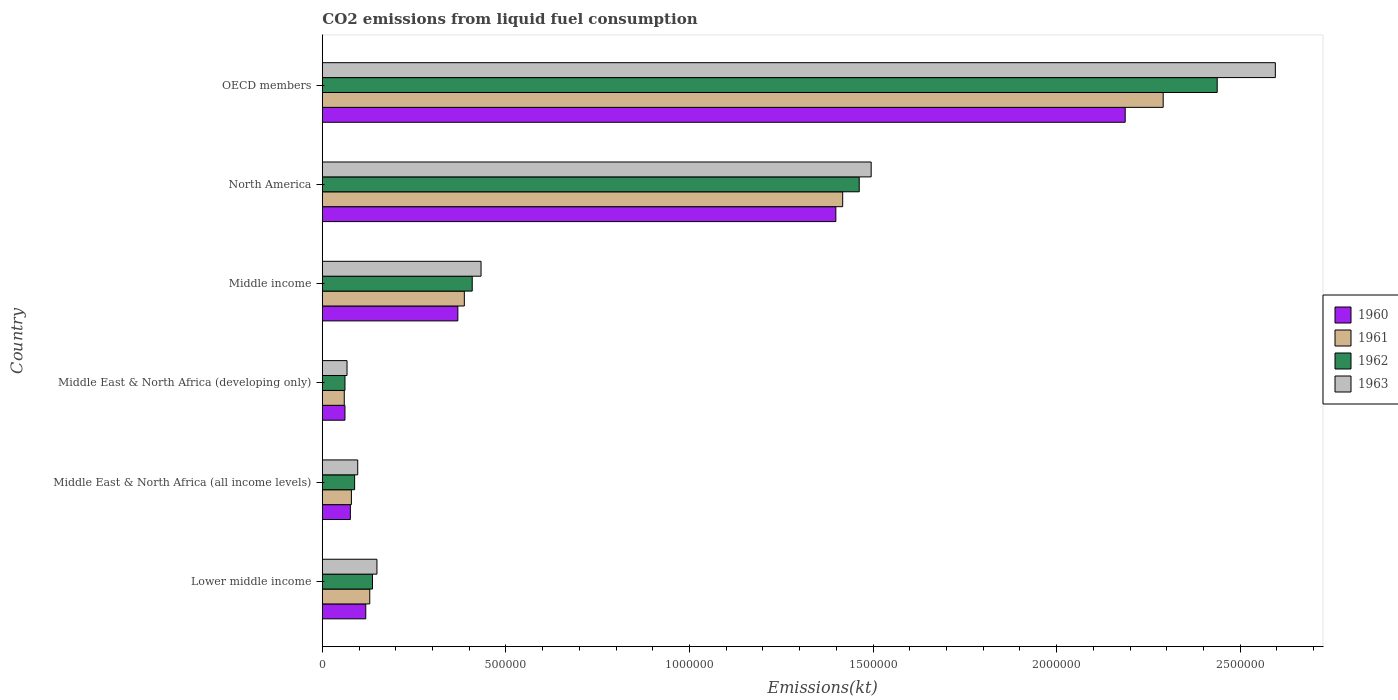How many different coloured bars are there?
Give a very brief answer. 4. How many groups of bars are there?
Keep it short and to the point. 6. Are the number of bars on each tick of the Y-axis equal?
Keep it short and to the point. Yes. How many bars are there on the 3rd tick from the top?
Offer a terse response. 4. How many bars are there on the 2nd tick from the bottom?
Provide a succinct answer. 4. What is the label of the 3rd group of bars from the top?
Your answer should be very brief. Middle income. In how many cases, is the number of bars for a given country not equal to the number of legend labels?
Make the answer very short. 0. What is the amount of CO2 emitted in 1960 in Middle East & North Africa (developing only)?
Offer a very short reply. 6.16e+04. Across all countries, what is the maximum amount of CO2 emitted in 1960?
Give a very brief answer. 2.19e+06. Across all countries, what is the minimum amount of CO2 emitted in 1963?
Offer a very short reply. 6.73e+04. In which country was the amount of CO2 emitted in 1960 maximum?
Ensure brevity in your answer.  OECD members. In which country was the amount of CO2 emitted in 1960 minimum?
Ensure brevity in your answer.  Middle East & North Africa (developing only). What is the total amount of CO2 emitted in 1962 in the graph?
Your response must be concise. 4.59e+06. What is the difference between the amount of CO2 emitted in 1962 in Middle East & North Africa (all income levels) and that in Middle income?
Provide a short and direct response. -3.20e+05. What is the difference between the amount of CO2 emitted in 1961 in Middle income and the amount of CO2 emitted in 1962 in Middle East & North Africa (developing only)?
Your answer should be very brief. 3.25e+05. What is the average amount of CO2 emitted in 1961 per country?
Offer a very short reply. 7.27e+05. What is the difference between the amount of CO2 emitted in 1963 and amount of CO2 emitted in 1962 in Middle East & North Africa (developing only)?
Keep it short and to the point. 5626.64. In how many countries, is the amount of CO2 emitted in 1961 greater than 2300000 kt?
Provide a short and direct response. 0. What is the ratio of the amount of CO2 emitted in 1960 in North America to that in OECD members?
Offer a very short reply. 0.64. Is the amount of CO2 emitted in 1963 in Lower middle income less than that in Middle income?
Provide a short and direct response. Yes. Is the difference between the amount of CO2 emitted in 1963 in Lower middle income and Middle East & North Africa (all income levels) greater than the difference between the amount of CO2 emitted in 1962 in Lower middle income and Middle East & North Africa (all income levels)?
Your answer should be compact. Yes. What is the difference between the highest and the second highest amount of CO2 emitted in 1960?
Your answer should be very brief. 7.88e+05. What is the difference between the highest and the lowest amount of CO2 emitted in 1962?
Your answer should be very brief. 2.38e+06. Is the sum of the amount of CO2 emitted in 1961 in Lower middle income and Middle East & North Africa (developing only) greater than the maximum amount of CO2 emitted in 1960 across all countries?
Your response must be concise. No. What does the 2nd bar from the bottom in OECD members represents?
Offer a very short reply. 1961. Are all the bars in the graph horizontal?
Your response must be concise. Yes. How many countries are there in the graph?
Provide a succinct answer. 6. What is the difference between two consecutive major ticks on the X-axis?
Give a very brief answer. 5.00e+05. Are the values on the major ticks of X-axis written in scientific E-notation?
Ensure brevity in your answer.  No. Does the graph contain grids?
Offer a very short reply. No. Where does the legend appear in the graph?
Your response must be concise. Center right. How many legend labels are there?
Provide a succinct answer. 4. What is the title of the graph?
Make the answer very short. CO2 emissions from liquid fuel consumption. What is the label or title of the X-axis?
Keep it short and to the point. Emissions(kt). What is the Emissions(kt) of 1960 in Lower middle income?
Ensure brevity in your answer.  1.18e+05. What is the Emissions(kt) in 1961 in Lower middle income?
Provide a succinct answer. 1.29e+05. What is the Emissions(kt) of 1962 in Lower middle income?
Provide a short and direct response. 1.37e+05. What is the Emissions(kt) in 1963 in Lower middle income?
Offer a terse response. 1.49e+05. What is the Emissions(kt) of 1960 in Middle East & North Africa (all income levels)?
Give a very brief answer. 7.64e+04. What is the Emissions(kt) in 1961 in Middle East & North Africa (all income levels)?
Your answer should be compact. 7.92e+04. What is the Emissions(kt) of 1962 in Middle East & North Africa (all income levels)?
Offer a very short reply. 8.80e+04. What is the Emissions(kt) in 1963 in Middle East & North Africa (all income levels)?
Your answer should be very brief. 9.64e+04. What is the Emissions(kt) of 1960 in Middle East & North Africa (developing only)?
Your answer should be compact. 6.16e+04. What is the Emissions(kt) in 1961 in Middle East & North Africa (developing only)?
Your answer should be compact. 5.98e+04. What is the Emissions(kt) in 1962 in Middle East & North Africa (developing only)?
Your answer should be compact. 6.17e+04. What is the Emissions(kt) in 1963 in Middle East & North Africa (developing only)?
Offer a terse response. 6.73e+04. What is the Emissions(kt) in 1960 in Middle income?
Your answer should be very brief. 3.69e+05. What is the Emissions(kt) of 1961 in Middle income?
Give a very brief answer. 3.87e+05. What is the Emissions(kt) in 1962 in Middle income?
Your answer should be compact. 4.08e+05. What is the Emissions(kt) in 1963 in Middle income?
Offer a terse response. 4.32e+05. What is the Emissions(kt) of 1960 in North America?
Ensure brevity in your answer.  1.40e+06. What is the Emissions(kt) of 1961 in North America?
Provide a succinct answer. 1.42e+06. What is the Emissions(kt) of 1962 in North America?
Make the answer very short. 1.46e+06. What is the Emissions(kt) in 1963 in North America?
Offer a very short reply. 1.49e+06. What is the Emissions(kt) in 1960 in OECD members?
Provide a succinct answer. 2.19e+06. What is the Emissions(kt) of 1961 in OECD members?
Provide a succinct answer. 2.29e+06. What is the Emissions(kt) of 1962 in OECD members?
Provide a short and direct response. 2.44e+06. What is the Emissions(kt) of 1963 in OECD members?
Your answer should be very brief. 2.60e+06. Across all countries, what is the maximum Emissions(kt) in 1960?
Your answer should be compact. 2.19e+06. Across all countries, what is the maximum Emissions(kt) of 1961?
Your response must be concise. 2.29e+06. Across all countries, what is the maximum Emissions(kt) of 1962?
Offer a very short reply. 2.44e+06. Across all countries, what is the maximum Emissions(kt) of 1963?
Provide a short and direct response. 2.60e+06. Across all countries, what is the minimum Emissions(kt) of 1960?
Your answer should be very brief. 6.16e+04. Across all countries, what is the minimum Emissions(kt) of 1961?
Your answer should be very brief. 5.98e+04. Across all countries, what is the minimum Emissions(kt) of 1962?
Give a very brief answer. 6.17e+04. Across all countries, what is the minimum Emissions(kt) of 1963?
Keep it short and to the point. 6.73e+04. What is the total Emissions(kt) in 1960 in the graph?
Your response must be concise. 4.21e+06. What is the total Emissions(kt) in 1961 in the graph?
Provide a succinct answer. 4.36e+06. What is the total Emissions(kt) of 1962 in the graph?
Make the answer very short. 4.59e+06. What is the total Emissions(kt) in 1963 in the graph?
Your answer should be very brief. 4.84e+06. What is the difference between the Emissions(kt) of 1960 in Lower middle income and that in Middle East & North Africa (all income levels)?
Give a very brief answer. 4.19e+04. What is the difference between the Emissions(kt) of 1961 in Lower middle income and that in Middle East & North Africa (all income levels)?
Offer a terse response. 5.00e+04. What is the difference between the Emissions(kt) in 1962 in Lower middle income and that in Middle East & North Africa (all income levels)?
Make the answer very short. 4.87e+04. What is the difference between the Emissions(kt) in 1963 in Lower middle income and that in Middle East & North Africa (all income levels)?
Your answer should be very brief. 5.23e+04. What is the difference between the Emissions(kt) of 1960 in Lower middle income and that in Middle East & North Africa (developing only)?
Make the answer very short. 5.67e+04. What is the difference between the Emissions(kt) in 1961 in Lower middle income and that in Middle East & North Africa (developing only)?
Make the answer very short. 6.95e+04. What is the difference between the Emissions(kt) in 1962 in Lower middle income and that in Middle East & North Africa (developing only)?
Your answer should be compact. 7.49e+04. What is the difference between the Emissions(kt) in 1963 in Lower middle income and that in Middle East & North Africa (developing only)?
Your answer should be very brief. 8.14e+04. What is the difference between the Emissions(kt) of 1960 in Lower middle income and that in Middle income?
Keep it short and to the point. -2.51e+05. What is the difference between the Emissions(kt) in 1961 in Lower middle income and that in Middle income?
Provide a succinct answer. -2.58e+05. What is the difference between the Emissions(kt) in 1962 in Lower middle income and that in Middle income?
Offer a very short reply. -2.72e+05. What is the difference between the Emissions(kt) of 1963 in Lower middle income and that in Middle income?
Your answer should be very brief. -2.84e+05. What is the difference between the Emissions(kt) of 1960 in Lower middle income and that in North America?
Offer a very short reply. -1.28e+06. What is the difference between the Emissions(kt) in 1961 in Lower middle income and that in North America?
Your answer should be very brief. -1.29e+06. What is the difference between the Emissions(kt) in 1962 in Lower middle income and that in North America?
Make the answer very short. -1.33e+06. What is the difference between the Emissions(kt) of 1963 in Lower middle income and that in North America?
Your answer should be compact. -1.35e+06. What is the difference between the Emissions(kt) of 1960 in Lower middle income and that in OECD members?
Your answer should be very brief. -2.07e+06. What is the difference between the Emissions(kt) in 1961 in Lower middle income and that in OECD members?
Make the answer very short. -2.16e+06. What is the difference between the Emissions(kt) of 1962 in Lower middle income and that in OECD members?
Your answer should be compact. -2.30e+06. What is the difference between the Emissions(kt) of 1963 in Lower middle income and that in OECD members?
Ensure brevity in your answer.  -2.45e+06. What is the difference between the Emissions(kt) in 1960 in Middle East & North Africa (all income levels) and that in Middle East & North Africa (developing only)?
Give a very brief answer. 1.48e+04. What is the difference between the Emissions(kt) in 1961 in Middle East & North Africa (all income levels) and that in Middle East & North Africa (developing only)?
Provide a short and direct response. 1.94e+04. What is the difference between the Emissions(kt) of 1962 in Middle East & North Africa (all income levels) and that in Middle East & North Africa (developing only)?
Offer a terse response. 2.63e+04. What is the difference between the Emissions(kt) in 1963 in Middle East & North Africa (all income levels) and that in Middle East & North Africa (developing only)?
Provide a succinct answer. 2.91e+04. What is the difference between the Emissions(kt) of 1960 in Middle East & North Africa (all income levels) and that in Middle income?
Your response must be concise. -2.93e+05. What is the difference between the Emissions(kt) in 1961 in Middle East & North Africa (all income levels) and that in Middle income?
Ensure brevity in your answer.  -3.08e+05. What is the difference between the Emissions(kt) of 1962 in Middle East & North Africa (all income levels) and that in Middle income?
Your response must be concise. -3.20e+05. What is the difference between the Emissions(kt) in 1963 in Middle East & North Africa (all income levels) and that in Middle income?
Make the answer very short. -3.36e+05. What is the difference between the Emissions(kt) in 1960 in Middle East & North Africa (all income levels) and that in North America?
Keep it short and to the point. -1.32e+06. What is the difference between the Emissions(kt) in 1961 in Middle East & North Africa (all income levels) and that in North America?
Make the answer very short. -1.34e+06. What is the difference between the Emissions(kt) in 1962 in Middle East & North Africa (all income levels) and that in North America?
Keep it short and to the point. -1.37e+06. What is the difference between the Emissions(kt) in 1963 in Middle East & North Africa (all income levels) and that in North America?
Keep it short and to the point. -1.40e+06. What is the difference between the Emissions(kt) in 1960 in Middle East & North Africa (all income levels) and that in OECD members?
Your answer should be very brief. -2.11e+06. What is the difference between the Emissions(kt) of 1961 in Middle East & North Africa (all income levels) and that in OECD members?
Give a very brief answer. -2.21e+06. What is the difference between the Emissions(kt) in 1962 in Middle East & North Africa (all income levels) and that in OECD members?
Provide a short and direct response. -2.35e+06. What is the difference between the Emissions(kt) of 1963 in Middle East & North Africa (all income levels) and that in OECD members?
Keep it short and to the point. -2.50e+06. What is the difference between the Emissions(kt) in 1960 in Middle East & North Africa (developing only) and that in Middle income?
Give a very brief answer. -3.07e+05. What is the difference between the Emissions(kt) in 1961 in Middle East & North Africa (developing only) and that in Middle income?
Your response must be concise. -3.27e+05. What is the difference between the Emissions(kt) in 1962 in Middle East & North Africa (developing only) and that in Middle income?
Your answer should be compact. -3.47e+05. What is the difference between the Emissions(kt) in 1963 in Middle East & North Africa (developing only) and that in Middle income?
Your answer should be very brief. -3.65e+05. What is the difference between the Emissions(kt) in 1960 in Middle East & North Africa (developing only) and that in North America?
Make the answer very short. -1.34e+06. What is the difference between the Emissions(kt) in 1961 in Middle East & North Africa (developing only) and that in North America?
Keep it short and to the point. -1.36e+06. What is the difference between the Emissions(kt) of 1962 in Middle East & North Africa (developing only) and that in North America?
Ensure brevity in your answer.  -1.40e+06. What is the difference between the Emissions(kt) of 1963 in Middle East & North Africa (developing only) and that in North America?
Your response must be concise. -1.43e+06. What is the difference between the Emissions(kt) of 1960 in Middle East & North Africa (developing only) and that in OECD members?
Give a very brief answer. -2.13e+06. What is the difference between the Emissions(kt) of 1961 in Middle East & North Africa (developing only) and that in OECD members?
Provide a short and direct response. -2.23e+06. What is the difference between the Emissions(kt) of 1962 in Middle East & North Africa (developing only) and that in OECD members?
Your answer should be compact. -2.38e+06. What is the difference between the Emissions(kt) in 1963 in Middle East & North Africa (developing only) and that in OECD members?
Ensure brevity in your answer.  -2.53e+06. What is the difference between the Emissions(kt) in 1960 in Middle income and that in North America?
Provide a succinct answer. -1.03e+06. What is the difference between the Emissions(kt) in 1961 in Middle income and that in North America?
Offer a very short reply. -1.03e+06. What is the difference between the Emissions(kt) in 1962 in Middle income and that in North America?
Ensure brevity in your answer.  -1.05e+06. What is the difference between the Emissions(kt) of 1963 in Middle income and that in North America?
Give a very brief answer. -1.06e+06. What is the difference between the Emissions(kt) in 1960 in Middle income and that in OECD members?
Offer a terse response. -1.82e+06. What is the difference between the Emissions(kt) in 1961 in Middle income and that in OECD members?
Your answer should be very brief. -1.90e+06. What is the difference between the Emissions(kt) in 1962 in Middle income and that in OECD members?
Offer a terse response. -2.03e+06. What is the difference between the Emissions(kt) in 1963 in Middle income and that in OECD members?
Provide a short and direct response. -2.16e+06. What is the difference between the Emissions(kt) of 1960 in North America and that in OECD members?
Your response must be concise. -7.88e+05. What is the difference between the Emissions(kt) in 1961 in North America and that in OECD members?
Your answer should be very brief. -8.73e+05. What is the difference between the Emissions(kt) in 1962 in North America and that in OECD members?
Your response must be concise. -9.75e+05. What is the difference between the Emissions(kt) of 1963 in North America and that in OECD members?
Make the answer very short. -1.10e+06. What is the difference between the Emissions(kt) in 1960 in Lower middle income and the Emissions(kt) in 1961 in Middle East & North Africa (all income levels)?
Give a very brief answer. 3.91e+04. What is the difference between the Emissions(kt) of 1960 in Lower middle income and the Emissions(kt) of 1962 in Middle East & North Africa (all income levels)?
Provide a short and direct response. 3.03e+04. What is the difference between the Emissions(kt) in 1960 in Lower middle income and the Emissions(kt) in 1963 in Middle East & North Africa (all income levels)?
Keep it short and to the point. 2.19e+04. What is the difference between the Emissions(kt) of 1961 in Lower middle income and the Emissions(kt) of 1962 in Middle East & North Africa (all income levels)?
Your answer should be compact. 4.13e+04. What is the difference between the Emissions(kt) in 1961 in Lower middle income and the Emissions(kt) in 1963 in Middle East & North Africa (all income levels)?
Keep it short and to the point. 3.28e+04. What is the difference between the Emissions(kt) in 1962 in Lower middle income and the Emissions(kt) in 1963 in Middle East & North Africa (all income levels)?
Offer a very short reply. 4.02e+04. What is the difference between the Emissions(kt) of 1960 in Lower middle income and the Emissions(kt) of 1961 in Middle East & North Africa (developing only)?
Make the answer very short. 5.85e+04. What is the difference between the Emissions(kt) of 1960 in Lower middle income and the Emissions(kt) of 1962 in Middle East & North Africa (developing only)?
Your answer should be compact. 5.66e+04. What is the difference between the Emissions(kt) of 1960 in Lower middle income and the Emissions(kt) of 1963 in Middle East & North Africa (developing only)?
Provide a succinct answer. 5.10e+04. What is the difference between the Emissions(kt) of 1961 in Lower middle income and the Emissions(kt) of 1962 in Middle East & North Africa (developing only)?
Offer a terse response. 6.75e+04. What is the difference between the Emissions(kt) of 1961 in Lower middle income and the Emissions(kt) of 1963 in Middle East & North Africa (developing only)?
Make the answer very short. 6.19e+04. What is the difference between the Emissions(kt) in 1962 in Lower middle income and the Emissions(kt) in 1963 in Middle East & North Africa (developing only)?
Offer a very short reply. 6.93e+04. What is the difference between the Emissions(kt) of 1960 in Lower middle income and the Emissions(kt) of 1961 in Middle income?
Provide a succinct answer. -2.68e+05. What is the difference between the Emissions(kt) in 1960 in Lower middle income and the Emissions(kt) in 1962 in Middle income?
Keep it short and to the point. -2.90e+05. What is the difference between the Emissions(kt) of 1960 in Lower middle income and the Emissions(kt) of 1963 in Middle income?
Keep it short and to the point. -3.14e+05. What is the difference between the Emissions(kt) of 1961 in Lower middle income and the Emissions(kt) of 1962 in Middle income?
Offer a very short reply. -2.79e+05. What is the difference between the Emissions(kt) in 1961 in Lower middle income and the Emissions(kt) in 1963 in Middle income?
Offer a terse response. -3.03e+05. What is the difference between the Emissions(kt) of 1962 in Lower middle income and the Emissions(kt) of 1963 in Middle income?
Make the answer very short. -2.96e+05. What is the difference between the Emissions(kt) in 1960 in Lower middle income and the Emissions(kt) in 1961 in North America?
Your answer should be compact. -1.30e+06. What is the difference between the Emissions(kt) of 1960 in Lower middle income and the Emissions(kt) of 1962 in North America?
Keep it short and to the point. -1.34e+06. What is the difference between the Emissions(kt) of 1960 in Lower middle income and the Emissions(kt) of 1963 in North America?
Give a very brief answer. -1.38e+06. What is the difference between the Emissions(kt) in 1961 in Lower middle income and the Emissions(kt) in 1962 in North America?
Your answer should be very brief. -1.33e+06. What is the difference between the Emissions(kt) of 1961 in Lower middle income and the Emissions(kt) of 1963 in North America?
Your response must be concise. -1.37e+06. What is the difference between the Emissions(kt) of 1962 in Lower middle income and the Emissions(kt) of 1963 in North America?
Make the answer very short. -1.36e+06. What is the difference between the Emissions(kt) of 1960 in Lower middle income and the Emissions(kt) of 1961 in OECD members?
Your answer should be compact. -2.17e+06. What is the difference between the Emissions(kt) of 1960 in Lower middle income and the Emissions(kt) of 1962 in OECD members?
Make the answer very short. -2.32e+06. What is the difference between the Emissions(kt) in 1960 in Lower middle income and the Emissions(kt) in 1963 in OECD members?
Provide a short and direct response. -2.48e+06. What is the difference between the Emissions(kt) of 1961 in Lower middle income and the Emissions(kt) of 1962 in OECD members?
Make the answer very short. -2.31e+06. What is the difference between the Emissions(kt) in 1961 in Lower middle income and the Emissions(kt) in 1963 in OECD members?
Give a very brief answer. -2.47e+06. What is the difference between the Emissions(kt) in 1962 in Lower middle income and the Emissions(kt) in 1963 in OECD members?
Ensure brevity in your answer.  -2.46e+06. What is the difference between the Emissions(kt) in 1960 in Middle East & North Africa (all income levels) and the Emissions(kt) in 1961 in Middle East & North Africa (developing only)?
Provide a short and direct response. 1.66e+04. What is the difference between the Emissions(kt) in 1960 in Middle East & North Africa (all income levels) and the Emissions(kt) in 1962 in Middle East & North Africa (developing only)?
Offer a very short reply. 1.47e+04. What is the difference between the Emissions(kt) of 1960 in Middle East & North Africa (all income levels) and the Emissions(kt) of 1963 in Middle East & North Africa (developing only)?
Provide a succinct answer. 9054.3. What is the difference between the Emissions(kt) of 1961 in Middle East & North Africa (all income levels) and the Emissions(kt) of 1962 in Middle East & North Africa (developing only)?
Make the answer very short. 1.75e+04. What is the difference between the Emissions(kt) of 1961 in Middle East & North Africa (all income levels) and the Emissions(kt) of 1963 in Middle East & North Africa (developing only)?
Keep it short and to the point. 1.19e+04. What is the difference between the Emissions(kt) of 1962 in Middle East & North Africa (all income levels) and the Emissions(kt) of 1963 in Middle East & North Africa (developing only)?
Offer a terse response. 2.07e+04. What is the difference between the Emissions(kt) of 1960 in Middle East & North Africa (all income levels) and the Emissions(kt) of 1961 in Middle income?
Ensure brevity in your answer.  -3.10e+05. What is the difference between the Emissions(kt) of 1960 in Middle East & North Africa (all income levels) and the Emissions(kt) of 1962 in Middle income?
Offer a very short reply. -3.32e+05. What is the difference between the Emissions(kt) of 1960 in Middle East & North Africa (all income levels) and the Emissions(kt) of 1963 in Middle income?
Keep it short and to the point. -3.56e+05. What is the difference between the Emissions(kt) in 1961 in Middle East & North Africa (all income levels) and the Emissions(kt) in 1962 in Middle income?
Offer a very short reply. -3.29e+05. What is the difference between the Emissions(kt) in 1961 in Middle East & North Africa (all income levels) and the Emissions(kt) in 1963 in Middle income?
Offer a very short reply. -3.53e+05. What is the difference between the Emissions(kt) in 1962 in Middle East & North Africa (all income levels) and the Emissions(kt) in 1963 in Middle income?
Keep it short and to the point. -3.44e+05. What is the difference between the Emissions(kt) in 1960 in Middle East & North Africa (all income levels) and the Emissions(kt) in 1961 in North America?
Provide a succinct answer. -1.34e+06. What is the difference between the Emissions(kt) of 1960 in Middle East & North Africa (all income levels) and the Emissions(kt) of 1962 in North America?
Offer a very short reply. -1.39e+06. What is the difference between the Emissions(kt) in 1960 in Middle East & North Africa (all income levels) and the Emissions(kt) in 1963 in North America?
Provide a succinct answer. -1.42e+06. What is the difference between the Emissions(kt) in 1961 in Middle East & North Africa (all income levels) and the Emissions(kt) in 1962 in North America?
Your response must be concise. -1.38e+06. What is the difference between the Emissions(kt) of 1961 in Middle East & North Africa (all income levels) and the Emissions(kt) of 1963 in North America?
Give a very brief answer. -1.42e+06. What is the difference between the Emissions(kt) in 1962 in Middle East & North Africa (all income levels) and the Emissions(kt) in 1963 in North America?
Offer a terse response. -1.41e+06. What is the difference between the Emissions(kt) of 1960 in Middle East & North Africa (all income levels) and the Emissions(kt) of 1961 in OECD members?
Your response must be concise. -2.21e+06. What is the difference between the Emissions(kt) in 1960 in Middle East & North Africa (all income levels) and the Emissions(kt) in 1962 in OECD members?
Offer a very short reply. -2.36e+06. What is the difference between the Emissions(kt) of 1960 in Middle East & North Africa (all income levels) and the Emissions(kt) of 1963 in OECD members?
Your response must be concise. -2.52e+06. What is the difference between the Emissions(kt) in 1961 in Middle East & North Africa (all income levels) and the Emissions(kt) in 1962 in OECD members?
Offer a very short reply. -2.36e+06. What is the difference between the Emissions(kt) of 1961 in Middle East & North Africa (all income levels) and the Emissions(kt) of 1963 in OECD members?
Offer a very short reply. -2.52e+06. What is the difference between the Emissions(kt) in 1962 in Middle East & North Africa (all income levels) and the Emissions(kt) in 1963 in OECD members?
Your answer should be compact. -2.51e+06. What is the difference between the Emissions(kt) of 1960 in Middle East & North Africa (developing only) and the Emissions(kt) of 1961 in Middle income?
Offer a very short reply. -3.25e+05. What is the difference between the Emissions(kt) in 1960 in Middle East & North Africa (developing only) and the Emissions(kt) in 1962 in Middle income?
Ensure brevity in your answer.  -3.47e+05. What is the difference between the Emissions(kt) in 1960 in Middle East & North Africa (developing only) and the Emissions(kt) in 1963 in Middle income?
Ensure brevity in your answer.  -3.71e+05. What is the difference between the Emissions(kt) in 1961 in Middle East & North Africa (developing only) and the Emissions(kt) in 1962 in Middle income?
Your response must be concise. -3.49e+05. What is the difference between the Emissions(kt) in 1961 in Middle East & North Africa (developing only) and the Emissions(kt) in 1963 in Middle income?
Keep it short and to the point. -3.73e+05. What is the difference between the Emissions(kt) of 1962 in Middle East & North Africa (developing only) and the Emissions(kt) of 1963 in Middle income?
Give a very brief answer. -3.71e+05. What is the difference between the Emissions(kt) in 1960 in Middle East & North Africa (developing only) and the Emissions(kt) in 1961 in North America?
Offer a terse response. -1.36e+06. What is the difference between the Emissions(kt) of 1960 in Middle East & North Africa (developing only) and the Emissions(kt) of 1962 in North America?
Offer a very short reply. -1.40e+06. What is the difference between the Emissions(kt) of 1960 in Middle East & North Africa (developing only) and the Emissions(kt) of 1963 in North America?
Offer a terse response. -1.43e+06. What is the difference between the Emissions(kt) of 1961 in Middle East & North Africa (developing only) and the Emissions(kt) of 1962 in North America?
Give a very brief answer. -1.40e+06. What is the difference between the Emissions(kt) in 1961 in Middle East & North Africa (developing only) and the Emissions(kt) in 1963 in North America?
Keep it short and to the point. -1.44e+06. What is the difference between the Emissions(kt) of 1962 in Middle East & North Africa (developing only) and the Emissions(kt) of 1963 in North America?
Give a very brief answer. -1.43e+06. What is the difference between the Emissions(kt) of 1960 in Middle East & North Africa (developing only) and the Emissions(kt) of 1961 in OECD members?
Give a very brief answer. -2.23e+06. What is the difference between the Emissions(kt) of 1960 in Middle East & North Africa (developing only) and the Emissions(kt) of 1962 in OECD members?
Your answer should be very brief. -2.38e+06. What is the difference between the Emissions(kt) of 1960 in Middle East & North Africa (developing only) and the Emissions(kt) of 1963 in OECD members?
Your answer should be compact. -2.53e+06. What is the difference between the Emissions(kt) of 1961 in Middle East & North Africa (developing only) and the Emissions(kt) of 1962 in OECD members?
Your response must be concise. -2.38e+06. What is the difference between the Emissions(kt) of 1961 in Middle East & North Africa (developing only) and the Emissions(kt) of 1963 in OECD members?
Offer a terse response. -2.54e+06. What is the difference between the Emissions(kt) in 1962 in Middle East & North Africa (developing only) and the Emissions(kt) in 1963 in OECD members?
Provide a short and direct response. -2.53e+06. What is the difference between the Emissions(kt) of 1960 in Middle income and the Emissions(kt) of 1961 in North America?
Offer a terse response. -1.05e+06. What is the difference between the Emissions(kt) of 1960 in Middle income and the Emissions(kt) of 1962 in North America?
Offer a very short reply. -1.09e+06. What is the difference between the Emissions(kt) in 1960 in Middle income and the Emissions(kt) in 1963 in North America?
Your answer should be compact. -1.13e+06. What is the difference between the Emissions(kt) in 1961 in Middle income and the Emissions(kt) in 1962 in North America?
Your answer should be very brief. -1.08e+06. What is the difference between the Emissions(kt) in 1961 in Middle income and the Emissions(kt) in 1963 in North America?
Provide a succinct answer. -1.11e+06. What is the difference between the Emissions(kt) in 1962 in Middle income and the Emissions(kt) in 1963 in North America?
Your answer should be compact. -1.09e+06. What is the difference between the Emissions(kt) of 1960 in Middle income and the Emissions(kt) of 1961 in OECD members?
Provide a short and direct response. -1.92e+06. What is the difference between the Emissions(kt) of 1960 in Middle income and the Emissions(kt) of 1962 in OECD members?
Make the answer very short. -2.07e+06. What is the difference between the Emissions(kt) in 1960 in Middle income and the Emissions(kt) in 1963 in OECD members?
Offer a terse response. -2.23e+06. What is the difference between the Emissions(kt) in 1961 in Middle income and the Emissions(kt) in 1962 in OECD members?
Keep it short and to the point. -2.05e+06. What is the difference between the Emissions(kt) of 1961 in Middle income and the Emissions(kt) of 1963 in OECD members?
Your answer should be compact. -2.21e+06. What is the difference between the Emissions(kt) of 1962 in Middle income and the Emissions(kt) of 1963 in OECD members?
Ensure brevity in your answer.  -2.19e+06. What is the difference between the Emissions(kt) in 1960 in North America and the Emissions(kt) in 1961 in OECD members?
Provide a succinct answer. -8.92e+05. What is the difference between the Emissions(kt) in 1960 in North America and the Emissions(kt) in 1962 in OECD members?
Provide a succinct answer. -1.04e+06. What is the difference between the Emissions(kt) of 1960 in North America and the Emissions(kt) of 1963 in OECD members?
Your response must be concise. -1.20e+06. What is the difference between the Emissions(kt) in 1961 in North America and the Emissions(kt) in 1962 in OECD members?
Provide a short and direct response. -1.02e+06. What is the difference between the Emissions(kt) of 1961 in North America and the Emissions(kt) of 1963 in OECD members?
Offer a very short reply. -1.18e+06. What is the difference between the Emissions(kt) of 1962 in North America and the Emissions(kt) of 1963 in OECD members?
Your answer should be very brief. -1.13e+06. What is the average Emissions(kt) in 1960 per country?
Your answer should be very brief. 7.02e+05. What is the average Emissions(kt) of 1961 per country?
Keep it short and to the point. 7.27e+05. What is the average Emissions(kt) in 1962 per country?
Provide a short and direct response. 7.66e+05. What is the average Emissions(kt) of 1963 per country?
Provide a succinct answer. 8.06e+05. What is the difference between the Emissions(kt) of 1960 and Emissions(kt) of 1961 in Lower middle income?
Your answer should be compact. -1.09e+04. What is the difference between the Emissions(kt) in 1960 and Emissions(kt) in 1962 in Lower middle income?
Offer a terse response. -1.83e+04. What is the difference between the Emissions(kt) of 1960 and Emissions(kt) of 1963 in Lower middle income?
Your answer should be very brief. -3.04e+04. What is the difference between the Emissions(kt) in 1961 and Emissions(kt) in 1962 in Lower middle income?
Give a very brief answer. -7400.19. What is the difference between the Emissions(kt) in 1961 and Emissions(kt) in 1963 in Lower middle income?
Give a very brief answer. -1.95e+04. What is the difference between the Emissions(kt) in 1962 and Emissions(kt) in 1963 in Lower middle income?
Your response must be concise. -1.21e+04. What is the difference between the Emissions(kt) in 1960 and Emissions(kt) in 1961 in Middle East & North Africa (all income levels)?
Your answer should be compact. -2824.83. What is the difference between the Emissions(kt) of 1960 and Emissions(kt) of 1962 in Middle East & North Africa (all income levels)?
Your answer should be compact. -1.16e+04. What is the difference between the Emissions(kt) in 1960 and Emissions(kt) in 1963 in Middle East & North Africa (all income levels)?
Keep it short and to the point. -2.01e+04. What is the difference between the Emissions(kt) in 1961 and Emissions(kt) in 1962 in Middle East & North Africa (all income levels)?
Ensure brevity in your answer.  -8782.71. What is the difference between the Emissions(kt) in 1961 and Emissions(kt) in 1963 in Middle East & North Africa (all income levels)?
Your answer should be compact. -1.73e+04. What is the difference between the Emissions(kt) in 1962 and Emissions(kt) in 1963 in Middle East & North Africa (all income levels)?
Give a very brief answer. -8470.85. What is the difference between the Emissions(kt) of 1960 and Emissions(kt) of 1961 in Middle East & North Africa (developing only)?
Your answer should be very brief. 1849.85. What is the difference between the Emissions(kt) in 1960 and Emissions(kt) in 1962 in Middle East & North Africa (developing only)?
Ensure brevity in your answer.  -69.74. What is the difference between the Emissions(kt) of 1960 and Emissions(kt) of 1963 in Middle East & North Africa (developing only)?
Provide a short and direct response. -5696.37. What is the difference between the Emissions(kt) of 1961 and Emissions(kt) of 1962 in Middle East & North Africa (developing only)?
Provide a succinct answer. -1919.59. What is the difference between the Emissions(kt) of 1961 and Emissions(kt) of 1963 in Middle East & North Africa (developing only)?
Offer a very short reply. -7546.22. What is the difference between the Emissions(kt) of 1962 and Emissions(kt) of 1963 in Middle East & North Africa (developing only)?
Give a very brief answer. -5626.64. What is the difference between the Emissions(kt) of 1960 and Emissions(kt) of 1961 in Middle income?
Give a very brief answer. -1.77e+04. What is the difference between the Emissions(kt) in 1960 and Emissions(kt) in 1962 in Middle income?
Your answer should be compact. -3.92e+04. What is the difference between the Emissions(kt) of 1960 and Emissions(kt) of 1963 in Middle income?
Keep it short and to the point. -6.32e+04. What is the difference between the Emissions(kt) in 1961 and Emissions(kt) in 1962 in Middle income?
Your response must be concise. -2.15e+04. What is the difference between the Emissions(kt) of 1961 and Emissions(kt) of 1963 in Middle income?
Ensure brevity in your answer.  -4.55e+04. What is the difference between the Emissions(kt) in 1962 and Emissions(kt) in 1963 in Middle income?
Ensure brevity in your answer.  -2.40e+04. What is the difference between the Emissions(kt) in 1960 and Emissions(kt) in 1961 in North America?
Provide a short and direct response. -1.86e+04. What is the difference between the Emissions(kt) of 1960 and Emissions(kt) of 1962 in North America?
Keep it short and to the point. -6.37e+04. What is the difference between the Emissions(kt) in 1960 and Emissions(kt) in 1963 in North America?
Ensure brevity in your answer.  -9.62e+04. What is the difference between the Emissions(kt) in 1961 and Emissions(kt) in 1962 in North America?
Offer a terse response. -4.51e+04. What is the difference between the Emissions(kt) of 1961 and Emissions(kt) of 1963 in North America?
Your answer should be very brief. -7.76e+04. What is the difference between the Emissions(kt) in 1962 and Emissions(kt) in 1963 in North America?
Make the answer very short. -3.25e+04. What is the difference between the Emissions(kt) in 1960 and Emissions(kt) in 1961 in OECD members?
Keep it short and to the point. -1.04e+05. What is the difference between the Emissions(kt) of 1960 and Emissions(kt) of 1962 in OECD members?
Your answer should be compact. -2.51e+05. What is the difference between the Emissions(kt) in 1960 and Emissions(kt) in 1963 in OECD members?
Offer a terse response. -4.09e+05. What is the difference between the Emissions(kt) in 1961 and Emissions(kt) in 1962 in OECD members?
Offer a very short reply. -1.47e+05. What is the difference between the Emissions(kt) of 1961 and Emissions(kt) of 1963 in OECD members?
Ensure brevity in your answer.  -3.05e+05. What is the difference between the Emissions(kt) of 1962 and Emissions(kt) of 1963 in OECD members?
Your answer should be very brief. -1.58e+05. What is the ratio of the Emissions(kt) of 1960 in Lower middle income to that in Middle East & North Africa (all income levels)?
Your response must be concise. 1.55. What is the ratio of the Emissions(kt) of 1961 in Lower middle income to that in Middle East & North Africa (all income levels)?
Ensure brevity in your answer.  1.63. What is the ratio of the Emissions(kt) of 1962 in Lower middle income to that in Middle East & North Africa (all income levels)?
Your answer should be compact. 1.55. What is the ratio of the Emissions(kt) of 1963 in Lower middle income to that in Middle East & North Africa (all income levels)?
Provide a short and direct response. 1.54. What is the ratio of the Emissions(kt) in 1960 in Lower middle income to that in Middle East & North Africa (developing only)?
Offer a very short reply. 1.92. What is the ratio of the Emissions(kt) of 1961 in Lower middle income to that in Middle East & North Africa (developing only)?
Your response must be concise. 2.16. What is the ratio of the Emissions(kt) in 1962 in Lower middle income to that in Middle East & North Africa (developing only)?
Offer a very short reply. 2.22. What is the ratio of the Emissions(kt) in 1963 in Lower middle income to that in Middle East & North Africa (developing only)?
Your answer should be compact. 2.21. What is the ratio of the Emissions(kt) of 1960 in Lower middle income to that in Middle income?
Your answer should be compact. 0.32. What is the ratio of the Emissions(kt) of 1961 in Lower middle income to that in Middle income?
Your answer should be very brief. 0.33. What is the ratio of the Emissions(kt) in 1962 in Lower middle income to that in Middle income?
Make the answer very short. 0.33. What is the ratio of the Emissions(kt) of 1963 in Lower middle income to that in Middle income?
Provide a succinct answer. 0.34. What is the ratio of the Emissions(kt) of 1960 in Lower middle income to that in North America?
Offer a very short reply. 0.08. What is the ratio of the Emissions(kt) in 1961 in Lower middle income to that in North America?
Provide a short and direct response. 0.09. What is the ratio of the Emissions(kt) of 1962 in Lower middle income to that in North America?
Your response must be concise. 0.09. What is the ratio of the Emissions(kt) of 1963 in Lower middle income to that in North America?
Your answer should be compact. 0.1. What is the ratio of the Emissions(kt) of 1960 in Lower middle income to that in OECD members?
Provide a succinct answer. 0.05. What is the ratio of the Emissions(kt) of 1961 in Lower middle income to that in OECD members?
Provide a succinct answer. 0.06. What is the ratio of the Emissions(kt) in 1962 in Lower middle income to that in OECD members?
Make the answer very short. 0.06. What is the ratio of the Emissions(kt) in 1963 in Lower middle income to that in OECD members?
Your answer should be compact. 0.06. What is the ratio of the Emissions(kt) in 1960 in Middle East & North Africa (all income levels) to that in Middle East & North Africa (developing only)?
Provide a succinct answer. 1.24. What is the ratio of the Emissions(kt) of 1961 in Middle East & North Africa (all income levels) to that in Middle East & North Africa (developing only)?
Provide a succinct answer. 1.33. What is the ratio of the Emissions(kt) of 1962 in Middle East & North Africa (all income levels) to that in Middle East & North Africa (developing only)?
Your response must be concise. 1.43. What is the ratio of the Emissions(kt) of 1963 in Middle East & North Africa (all income levels) to that in Middle East & North Africa (developing only)?
Your response must be concise. 1.43. What is the ratio of the Emissions(kt) of 1960 in Middle East & North Africa (all income levels) to that in Middle income?
Your answer should be compact. 0.21. What is the ratio of the Emissions(kt) in 1961 in Middle East & North Africa (all income levels) to that in Middle income?
Provide a succinct answer. 0.2. What is the ratio of the Emissions(kt) of 1962 in Middle East & North Africa (all income levels) to that in Middle income?
Give a very brief answer. 0.22. What is the ratio of the Emissions(kt) in 1963 in Middle East & North Africa (all income levels) to that in Middle income?
Your answer should be compact. 0.22. What is the ratio of the Emissions(kt) of 1960 in Middle East & North Africa (all income levels) to that in North America?
Your answer should be very brief. 0.05. What is the ratio of the Emissions(kt) in 1961 in Middle East & North Africa (all income levels) to that in North America?
Keep it short and to the point. 0.06. What is the ratio of the Emissions(kt) in 1962 in Middle East & North Africa (all income levels) to that in North America?
Your answer should be very brief. 0.06. What is the ratio of the Emissions(kt) of 1963 in Middle East & North Africa (all income levels) to that in North America?
Offer a terse response. 0.06. What is the ratio of the Emissions(kt) in 1960 in Middle East & North Africa (all income levels) to that in OECD members?
Ensure brevity in your answer.  0.03. What is the ratio of the Emissions(kt) of 1961 in Middle East & North Africa (all income levels) to that in OECD members?
Provide a succinct answer. 0.03. What is the ratio of the Emissions(kt) of 1962 in Middle East & North Africa (all income levels) to that in OECD members?
Offer a terse response. 0.04. What is the ratio of the Emissions(kt) in 1963 in Middle East & North Africa (all income levels) to that in OECD members?
Your answer should be compact. 0.04. What is the ratio of the Emissions(kt) in 1960 in Middle East & North Africa (developing only) to that in Middle income?
Give a very brief answer. 0.17. What is the ratio of the Emissions(kt) in 1961 in Middle East & North Africa (developing only) to that in Middle income?
Provide a short and direct response. 0.15. What is the ratio of the Emissions(kt) in 1962 in Middle East & North Africa (developing only) to that in Middle income?
Give a very brief answer. 0.15. What is the ratio of the Emissions(kt) of 1963 in Middle East & North Africa (developing only) to that in Middle income?
Offer a terse response. 0.16. What is the ratio of the Emissions(kt) of 1960 in Middle East & North Africa (developing only) to that in North America?
Give a very brief answer. 0.04. What is the ratio of the Emissions(kt) in 1961 in Middle East & North Africa (developing only) to that in North America?
Your response must be concise. 0.04. What is the ratio of the Emissions(kt) of 1962 in Middle East & North Africa (developing only) to that in North America?
Provide a succinct answer. 0.04. What is the ratio of the Emissions(kt) of 1963 in Middle East & North Africa (developing only) to that in North America?
Ensure brevity in your answer.  0.04. What is the ratio of the Emissions(kt) of 1960 in Middle East & North Africa (developing only) to that in OECD members?
Offer a very short reply. 0.03. What is the ratio of the Emissions(kt) in 1961 in Middle East & North Africa (developing only) to that in OECD members?
Offer a terse response. 0.03. What is the ratio of the Emissions(kt) in 1962 in Middle East & North Africa (developing only) to that in OECD members?
Keep it short and to the point. 0.03. What is the ratio of the Emissions(kt) in 1963 in Middle East & North Africa (developing only) to that in OECD members?
Your answer should be compact. 0.03. What is the ratio of the Emissions(kt) of 1960 in Middle income to that in North America?
Make the answer very short. 0.26. What is the ratio of the Emissions(kt) in 1961 in Middle income to that in North America?
Make the answer very short. 0.27. What is the ratio of the Emissions(kt) of 1962 in Middle income to that in North America?
Provide a short and direct response. 0.28. What is the ratio of the Emissions(kt) in 1963 in Middle income to that in North America?
Offer a very short reply. 0.29. What is the ratio of the Emissions(kt) in 1960 in Middle income to that in OECD members?
Provide a succinct answer. 0.17. What is the ratio of the Emissions(kt) of 1961 in Middle income to that in OECD members?
Give a very brief answer. 0.17. What is the ratio of the Emissions(kt) in 1962 in Middle income to that in OECD members?
Your answer should be compact. 0.17. What is the ratio of the Emissions(kt) in 1963 in Middle income to that in OECD members?
Ensure brevity in your answer.  0.17. What is the ratio of the Emissions(kt) of 1960 in North America to that in OECD members?
Give a very brief answer. 0.64. What is the ratio of the Emissions(kt) of 1961 in North America to that in OECD members?
Ensure brevity in your answer.  0.62. What is the ratio of the Emissions(kt) in 1962 in North America to that in OECD members?
Your answer should be very brief. 0.6. What is the ratio of the Emissions(kt) in 1963 in North America to that in OECD members?
Your answer should be very brief. 0.58. What is the difference between the highest and the second highest Emissions(kt) of 1960?
Ensure brevity in your answer.  7.88e+05. What is the difference between the highest and the second highest Emissions(kt) in 1961?
Provide a succinct answer. 8.73e+05. What is the difference between the highest and the second highest Emissions(kt) of 1962?
Provide a succinct answer. 9.75e+05. What is the difference between the highest and the second highest Emissions(kt) in 1963?
Provide a succinct answer. 1.10e+06. What is the difference between the highest and the lowest Emissions(kt) in 1960?
Give a very brief answer. 2.13e+06. What is the difference between the highest and the lowest Emissions(kt) of 1961?
Offer a very short reply. 2.23e+06. What is the difference between the highest and the lowest Emissions(kt) of 1962?
Your response must be concise. 2.38e+06. What is the difference between the highest and the lowest Emissions(kt) of 1963?
Offer a very short reply. 2.53e+06. 